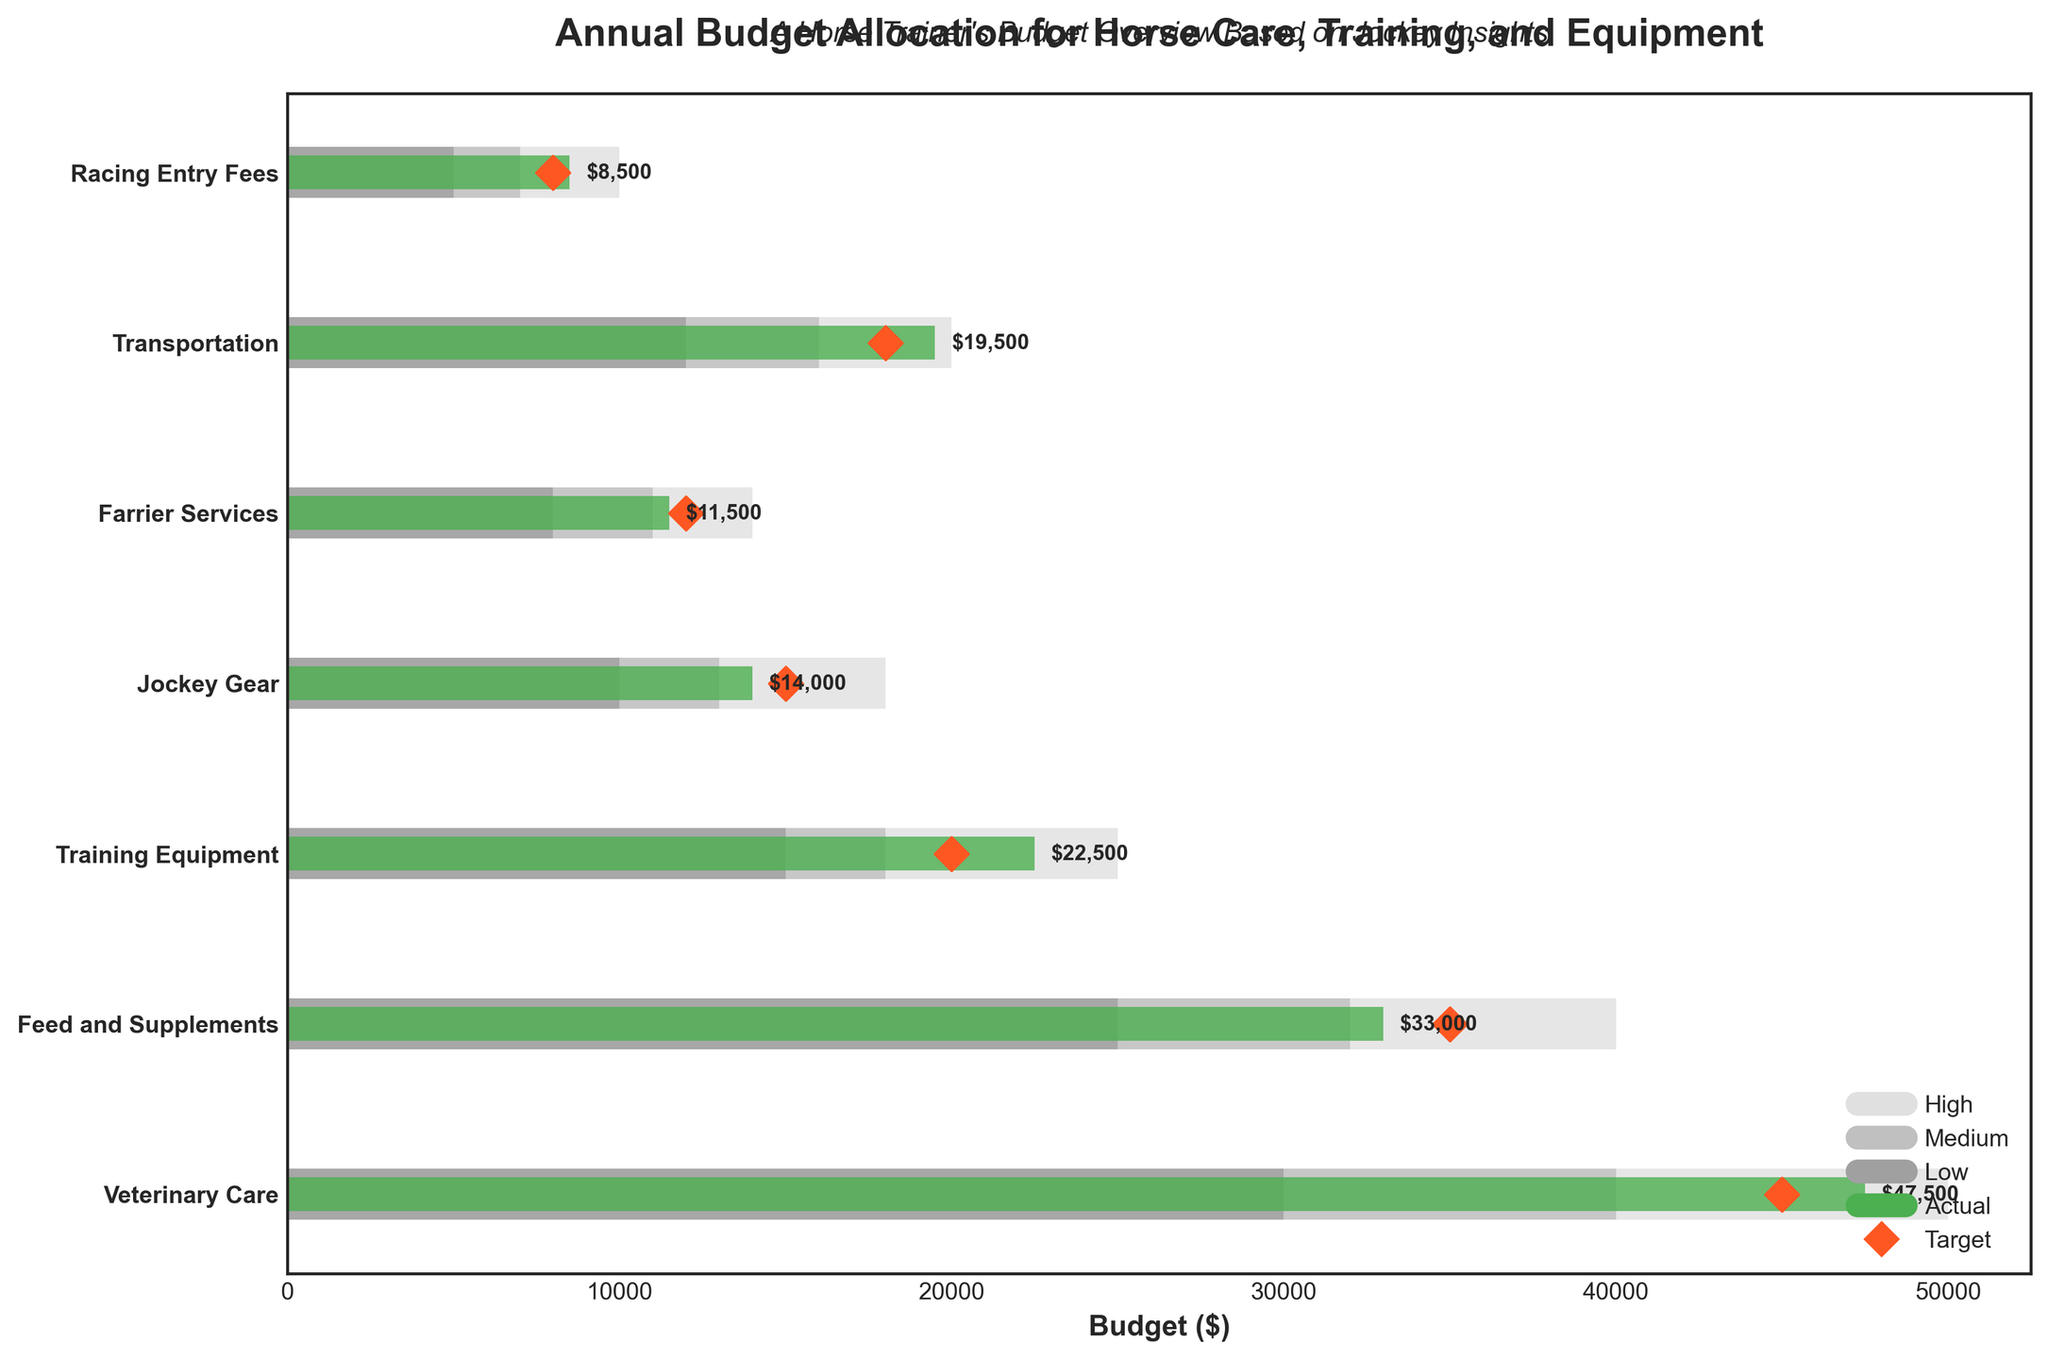How much was the actual spending on Veterinary Care compared to the target? The target spending on Veterinary Care was $45,000, and the actual spending was $47,500. To compare, confirm the values from the graph's labels and compare directly.
Answer: $47,500 vs $45,000 What is the title of the chart? The title of the chart is written at the top of the figure. It states, "Annual Budget Allocation for Horse Care, Training, and Equipment."
Answer: Annual Budget Allocation for Horse Care, Training, and Equipment Which category exceeded its target by the largest amount? Look at the categories and compare the difference between the actual and target spending for each. In this case, Veterinary Care exceeded its target by the largest amount ($47,500 - $45,000 = $2,500).
Answer: Veterinary Care What is the color used to represent actual spending in the chart? Identify the color of the bars representing the actual spending. In the chart, the bars representing actual spending are green.
Answer: Green Which category had the actual spending closest to its respective target? Calculate the absolute difference between the actual and target for each category. Jockey Gear had the smallest difference of $1,000 ($15,000 - $14,000).
Answer: Jockey Gear What is the actual spending on Training Equipment? The actual spending values are represented by the bar lengths and labeled on each bar. The actual spending on Training Equipment is $22,500.
Answer: $22,500 What is the target value for Racing Entry Fees? The target values are shown by red diamond shapes for each category. The target for Racing Entry Fees is $8,000.
Answer: $8,000 Which category's actual spending fell below its medium-range budget guideline? Identify the medium-range budget guideline from the gray bar lengths and compare it to actual spending. Feed and Supplements ($33,000) falls below its medium-range guideline of $32,000 to $40,000.
Answer: Feed and Supplements How much more was spent on Transportation than on Farrier Services? Find the actual spending for Transportation ($19,500) and Farrier Services ($11,500), then calculate the difference, $19,500 - $11,500 = $8,000.
Answer: $8,000 Which categories' actual spending surpassed their high-range budget guideline? Check the high-range budget guideline for each category and compare it to actual spending. Veterinary Care and Transportation surpassed their high-range guidelines.
Answer: Veterinary Care, Transportation 